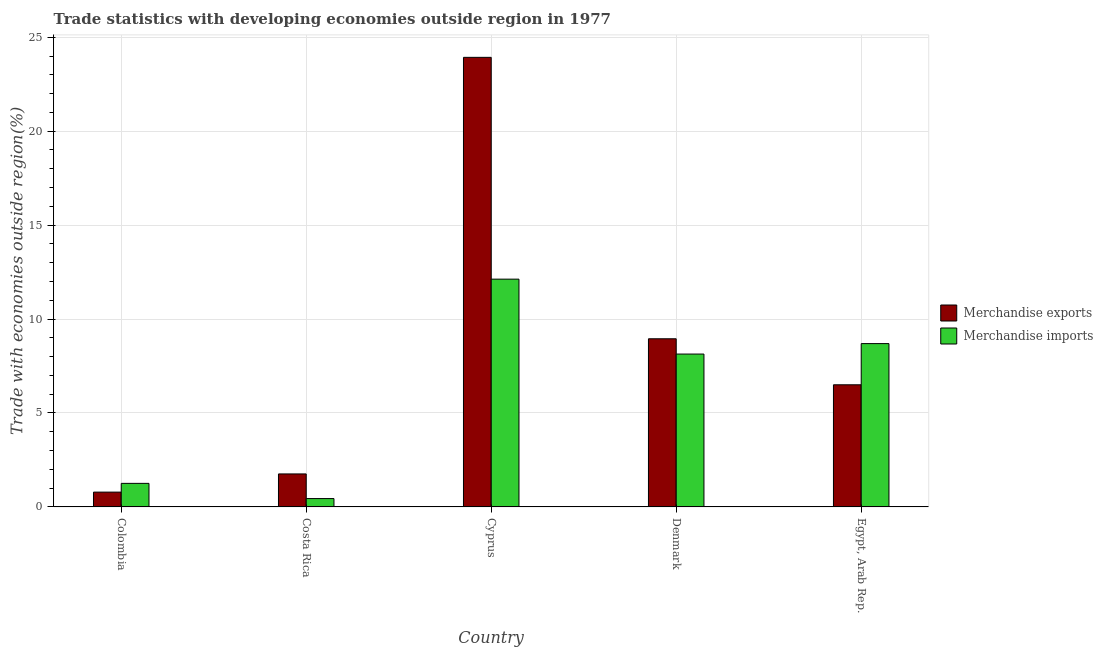How many different coloured bars are there?
Give a very brief answer. 2. How many groups of bars are there?
Keep it short and to the point. 5. Are the number of bars per tick equal to the number of legend labels?
Keep it short and to the point. Yes. What is the label of the 4th group of bars from the left?
Your response must be concise. Denmark. What is the merchandise exports in Cyprus?
Provide a succinct answer. 23.93. Across all countries, what is the maximum merchandise exports?
Make the answer very short. 23.93. Across all countries, what is the minimum merchandise exports?
Offer a terse response. 0.79. In which country was the merchandise imports maximum?
Give a very brief answer. Cyprus. What is the total merchandise exports in the graph?
Offer a terse response. 41.93. What is the difference between the merchandise imports in Colombia and that in Costa Rica?
Your answer should be very brief. 0.81. What is the difference between the merchandise exports in Cyprus and the merchandise imports in Egypt, Arab Rep.?
Make the answer very short. 15.24. What is the average merchandise imports per country?
Offer a very short reply. 6.13. What is the difference between the merchandise exports and merchandise imports in Egypt, Arab Rep.?
Your answer should be compact. -2.19. In how many countries, is the merchandise imports greater than 14 %?
Your response must be concise. 0. What is the ratio of the merchandise exports in Costa Rica to that in Denmark?
Your answer should be very brief. 0.2. Is the difference between the merchandise imports in Costa Rica and Egypt, Arab Rep. greater than the difference between the merchandise exports in Costa Rica and Egypt, Arab Rep.?
Your answer should be very brief. No. What is the difference between the highest and the second highest merchandise imports?
Your answer should be compact. 3.43. What is the difference between the highest and the lowest merchandise imports?
Provide a short and direct response. 11.68. Is the sum of the merchandise imports in Costa Rica and Cyprus greater than the maximum merchandise exports across all countries?
Provide a short and direct response. No. How many bars are there?
Keep it short and to the point. 10. Are all the bars in the graph horizontal?
Keep it short and to the point. No. What is the difference between two consecutive major ticks on the Y-axis?
Give a very brief answer. 5. Are the values on the major ticks of Y-axis written in scientific E-notation?
Your response must be concise. No. Does the graph contain any zero values?
Ensure brevity in your answer.  No. Does the graph contain grids?
Provide a succinct answer. Yes. Where does the legend appear in the graph?
Your response must be concise. Center right. What is the title of the graph?
Provide a short and direct response. Trade statistics with developing economies outside region in 1977. Does "All education staff compensation" appear as one of the legend labels in the graph?
Your response must be concise. No. What is the label or title of the Y-axis?
Offer a terse response. Trade with economies outside region(%). What is the Trade with economies outside region(%) in Merchandise exports in Colombia?
Offer a terse response. 0.79. What is the Trade with economies outside region(%) in Merchandise imports in Colombia?
Provide a short and direct response. 1.25. What is the Trade with economies outside region(%) of Merchandise exports in Costa Rica?
Ensure brevity in your answer.  1.76. What is the Trade with economies outside region(%) of Merchandise imports in Costa Rica?
Make the answer very short. 0.45. What is the Trade with economies outside region(%) of Merchandise exports in Cyprus?
Provide a short and direct response. 23.93. What is the Trade with economies outside region(%) in Merchandise imports in Cyprus?
Offer a terse response. 12.13. What is the Trade with economies outside region(%) in Merchandise exports in Denmark?
Provide a short and direct response. 8.95. What is the Trade with economies outside region(%) in Merchandise imports in Denmark?
Your response must be concise. 8.14. What is the Trade with economies outside region(%) of Merchandise exports in Egypt, Arab Rep.?
Make the answer very short. 6.5. What is the Trade with economies outside region(%) of Merchandise imports in Egypt, Arab Rep.?
Offer a very short reply. 8.69. Across all countries, what is the maximum Trade with economies outside region(%) of Merchandise exports?
Provide a short and direct response. 23.93. Across all countries, what is the maximum Trade with economies outside region(%) of Merchandise imports?
Offer a very short reply. 12.13. Across all countries, what is the minimum Trade with economies outside region(%) of Merchandise exports?
Provide a short and direct response. 0.79. Across all countries, what is the minimum Trade with economies outside region(%) of Merchandise imports?
Your answer should be compact. 0.45. What is the total Trade with economies outside region(%) of Merchandise exports in the graph?
Make the answer very short. 41.93. What is the total Trade with economies outside region(%) in Merchandise imports in the graph?
Keep it short and to the point. 30.66. What is the difference between the Trade with economies outside region(%) of Merchandise exports in Colombia and that in Costa Rica?
Offer a very short reply. -0.97. What is the difference between the Trade with economies outside region(%) of Merchandise imports in Colombia and that in Costa Rica?
Make the answer very short. 0.81. What is the difference between the Trade with economies outside region(%) of Merchandise exports in Colombia and that in Cyprus?
Give a very brief answer. -23.14. What is the difference between the Trade with economies outside region(%) of Merchandise imports in Colombia and that in Cyprus?
Give a very brief answer. -10.87. What is the difference between the Trade with economies outside region(%) in Merchandise exports in Colombia and that in Denmark?
Your answer should be compact. -8.16. What is the difference between the Trade with economies outside region(%) in Merchandise imports in Colombia and that in Denmark?
Keep it short and to the point. -6.88. What is the difference between the Trade with economies outside region(%) of Merchandise exports in Colombia and that in Egypt, Arab Rep.?
Your answer should be compact. -5.71. What is the difference between the Trade with economies outside region(%) of Merchandise imports in Colombia and that in Egypt, Arab Rep.?
Your answer should be compact. -7.44. What is the difference between the Trade with economies outside region(%) of Merchandise exports in Costa Rica and that in Cyprus?
Your answer should be very brief. -22.17. What is the difference between the Trade with economies outside region(%) of Merchandise imports in Costa Rica and that in Cyprus?
Your answer should be very brief. -11.68. What is the difference between the Trade with economies outside region(%) in Merchandise exports in Costa Rica and that in Denmark?
Offer a very short reply. -7.19. What is the difference between the Trade with economies outside region(%) of Merchandise imports in Costa Rica and that in Denmark?
Offer a terse response. -7.69. What is the difference between the Trade with economies outside region(%) in Merchandise exports in Costa Rica and that in Egypt, Arab Rep.?
Your answer should be very brief. -4.74. What is the difference between the Trade with economies outside region(%) of Merchandise imports in Costa Rica and that in Egypt, Arab Rep.?
Ensure brevity in your answer.  -8.25. What is the difference between the Trade with economies outside region(%) of Merchandise exports in Cyprus and that in Denmark?
Your response must be concise. 14.98. What is the difference between the Trade with economies outside region(%) of Merchandise imports in Cyprus and that in Denmark?
Keep it short and to the point. 3.99. What is the difference between the Trade with economies outside region(%) of Merchandise exports in Cyprus and that in Egypt, Arab Rep.?
Your response must be concise. 17.43. What is the difference between the Trade with economies outside region(%) in Merchandise imports in Cyprus and that in Egypt, Arab Rep.?
Offer a terse response. 3.43. What is the difference between the Trade with economies outside region(%) of Merchandise exports in Denmark and that in Egypt, Arab Rep.?
Provide a succinct answer. 2.45. What is the difference between the Trade with economies outside region(%) in Merchandise imports in Denmark and that in Egypt, Arab Rep.?
Ensure brevity in your answer.  -0.56. What is the difference between the Trade with economies outside region(%) of Merchandise exports in Colombia and the Trade with economies outside region(%) of Merchandise imports in Costa Rica?
Your answer should be compact. 0.34. What is the difference between the Trade with economies outside region(%) in Merchandise exports in Colombia and the Trade with economies outside region(%) in Merchandise imports in Cyprus?
Make the answer very short. -11.34. What is the difference between the Trade with economies outside region(%) of Merchandise exports in Colombia and the Trade with economies outside region(%) of Merchandise imports in Denmark?
Your response must be concise. -7.35. What is the difference between the Trade with economies outside region(%) in Merchandise exports in Colombia and the Trade with economies outside region(%) in Merchandise imports in Egypt, Arab Rep.?
Ensure brevity in your answer.  -7.91. What is the difference between the Trade with economies outside region(%) in Merchandise exports in Costa Rica and the Trade with economies outside region(%) in Merchandise imports in Cyprus?
Your answer should be compact. -10.37. What is the difference between the Trade with economies outside region(%) of Merchandise exports in Costa Rica and the Trade with economies outside region(%) of Merchandise imports in Denmark?
Your answer should be compact. -6.38. What is the difference between the Trade with economies outside region(%) of Merchandise exports in Costa Rica and the Trade with economies outside region(%) of Merchandise imports in Egypt, Arab Rep.?
Give a very brief answer. -6.94. What is the difference between the Trade with economies outside region(%) of Merchandise exports in Cyprus and the Trade with economies outside region(%) of Merchandise imports in Denmark?
Provide a short and direct response. 15.79. What is the difference between the Trade with economies outside region(%) of Merchandise exports in Cyprus and the Trade with economies outside region(%) of Merchandise imports in Egypt, Arab Rep.?
Keep it short and to the point. 15.24. What is the difference between the Trade with economies outside region(%) of Merchandise exports in Denmark and the Trade with economies outside region(%) of Merchandise imports in Egypt, Arab Rep.?
Offer a terse response. 0.26. What is the average Trade with economies outside region(%) of Merchandise exports per country?
Your response must be concise. 8.39. What is the average Trade with economies outside region(%) of Merchandise imports per country?
Provide a succinct answer. 6.13. What is the difference between the Trade with economies outside region(%) in Merchandise exports and Trade with economies outside region(%) in Merchandise imports in Colombia?
Give a very brief answer. -0.47. What is the difference between the Trade with economies outside region(%) of Merchandise exports and Trade with economies outside region(%) of Merchandise imports in Costa Rica?
Your answer should be compact. 1.31. What is the difference between the Trade with economies outside region(%) in Merchandise exports and Trade with economies outside region(%) in Merchandise imports in Cyprus?
Your answer should be very brief. 11.81. What is the difference between the Trade with economies outside region(%) in Merchandise exports and Trade with economies outside region(%) in Merchandise imports in Denmark?
Your answer should be compact. 0.81. What is the difference between the Trade with economies outside region(%) in Merchandise exports and Trade with economies outside region(%) in Merchandise imports in Egypt, Arab Rep.?
Your response must be concise. -2.19. What is the ratio of the Trade with economies outside region(%) of Merchandise exports in Colombia to that in Costa Rica?
Make the answer very short. 0.45. What is the ratio of the Trade with economies outside region(%) in Merchandise imports in Colombia to that in Costa Rica?
Provide a succinct answer. 2.82. What is the ratio of the Trade with economies outside region(%) of Merchandise exports in Colombia to that in Cyprus?
Give a very brief answer. 0.03. What is the ratio of the Trade with economies outside region(%) in Merchandise imports in Colombia to that in Cyprus?
Make the answer very short. 0.1. What is the ratio of the Trade with economies outside region(%) in Merchandise exports in Colombia to that in Denmark?
Offer a terse response. 0.09. What is the ratio of the Trade with economies outside region(%) in Merchandise imports in Colombia to that in Denmark?
Give a very brief answer. 0.15. What is the ratio of the Trade with economies outside region(%) in Merchandise exports in Colombia to that in Egypt, Arab Rep.?
Make the answer very short. 0.12. What is the ratio of the Trade with economies outside region(%) in Merchandise imports in Colombia to that in Egypt, Arab Rep.?
Offer a very short reply. 0.14. What is the ratio of the Trade with economies outside region(%) of Merchandise exports in Costa Rica to that in Cyprus?
Offer a terse response. 0.07. What is the ratio of the Trade with economies outside region(%) of Merchandise imports in Costa Rica to that in Cyprus?
Ensure brevity in your answer.  0.04. What is the ratio of the Trade with economies outside region(%) in Merchandise exports in Costa Rica to that in Denmark?
Your response must be concise. 0.2. What is the ratio of the Trade with economies outside region(%) in Merchandise imports in Costa Rica to that in Denmark?
Your response must be concise. 0.05. What is the ratio of the Trade with economies outside region(%) of Merchandise exports in Costa Rica to that in Egypt, Arab Rep.?
Provide a succinct answer. 0.27. What is the ratio of the Trade with economies outside region(%) in Merchandise imports in Costa Rica to that in Egypt, Arab Rep.?
Your answer should be compact. 0.05. What is the ratio of the Trade with economies outside region(%) in Merchandise exports in Cyprus to that in Denmark?
Your answer should be very brief. 2.67. What is the ratio of the Trade with economies outside region(%) in Merchandise imports in Cyprus to that in Denmark?
Ensure brevity in your answer.  1.49. What is the ratio of the Trade with economies outside region(%) of Merchandise exports in Cyprus to that in Egypt, Arab Rep.?
Provide a succinct answer. 3.68. What is the ratio of the Trade with economies outside region(%) in Merchandise imports in Cyprus to that in Egypt, Arab Rep.?
Provide a succinct answer. 1.39. What is the ratio of the Trade with economies outside region(%) of Merchandise exports in Denmark to that in Egypt, Arab Rep.?
Provide a short and direct response. 1.38. What is the ratio of the Trade with economies outside region(%) of Merchandise imports in Denmark to that in Egypt, Arab Rep.?
Give a very brief answer. 0.94. What is the difference between the highest and the second highest Trade with economies outside region(%) of Merchandise exports?
Provide a short and direct response. 14.98. What is the difference between the highest and the second highest Trade with economies outside region(%) in Merchandise imports?
Offer a terse response. 3.43. What is the difference between the highest and the lowest Trade with economies outside region(%) in Merchandise exports?
Offer a terse response. 23.14. What is the difference between the highest and the lowest Trade with economies outside region(%) of Merchandise imports?
Provide a short and direct response. 11.68. 